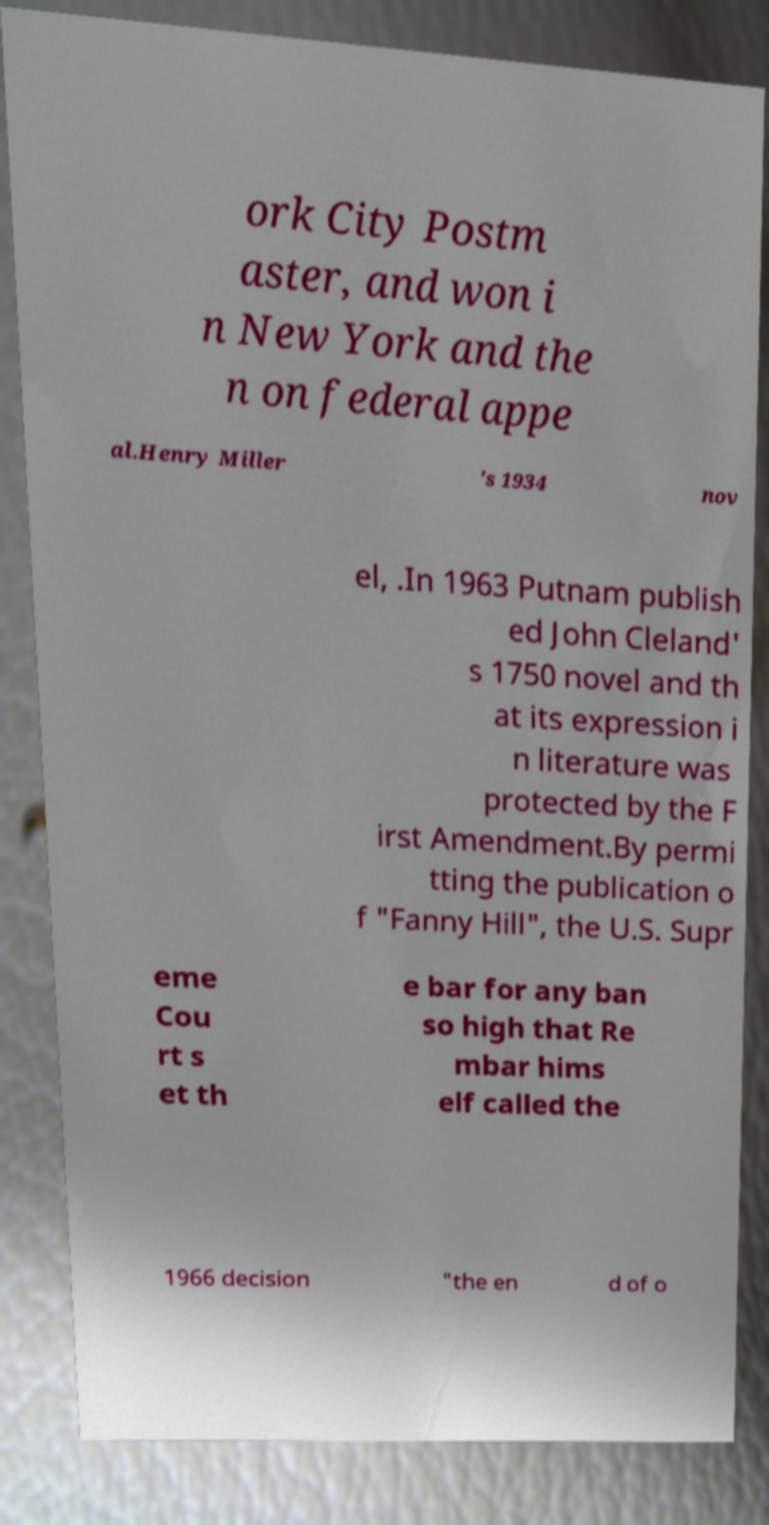For documentation purposes, I need the text within this image transcribed. Could you provide that? ork City Postm aster, and won i n New York and the n on federal appe al.Henry Miller 's 1934 nov el, .In 1963 Putnam publish ed John Cleland' s 1750 novel and th at its expression i n literature was protected by the F irst Amendment.By permi tting the publication o f "Fanny Hill", the U.S. Supr eme Cou rt s et th e bar for any ban so high that Re mbar hims elf called the 1966 decision "the en d of o 